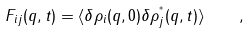Convert formula to latex. <formula><loc_0><loc_0><loc_500><loc_500>F _ { i j } ( q , t ) = \langle \delta \rho _ { i } ( q , 0 ) \delta \rho _ { j } ^ { ^ { * } } ( q , t ) \rangle \quad ,</formula> 